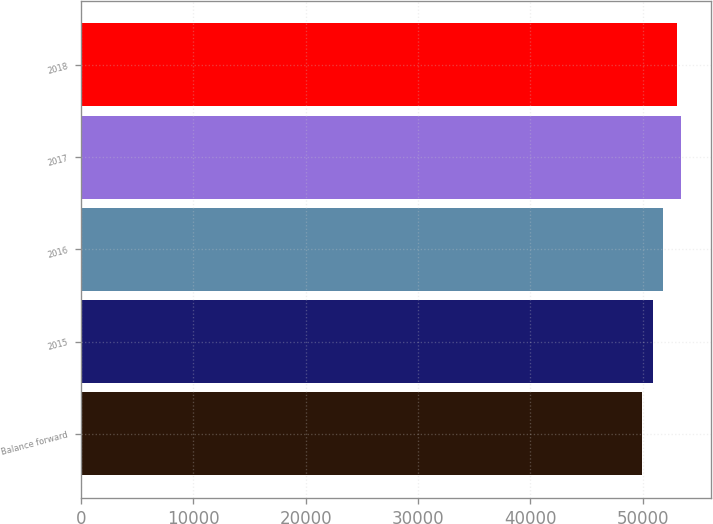<chart> <loc_0><loc_0><loc_500><loc_500><bar_chart><fcel>Balance forward<fcel>2015<fcel>2016<fcel>2017<fcel>2018<nl><fcel>49914<fcel>50927<fcel>51784<fcel>53399.4<fcel>53082<nl></chart> 